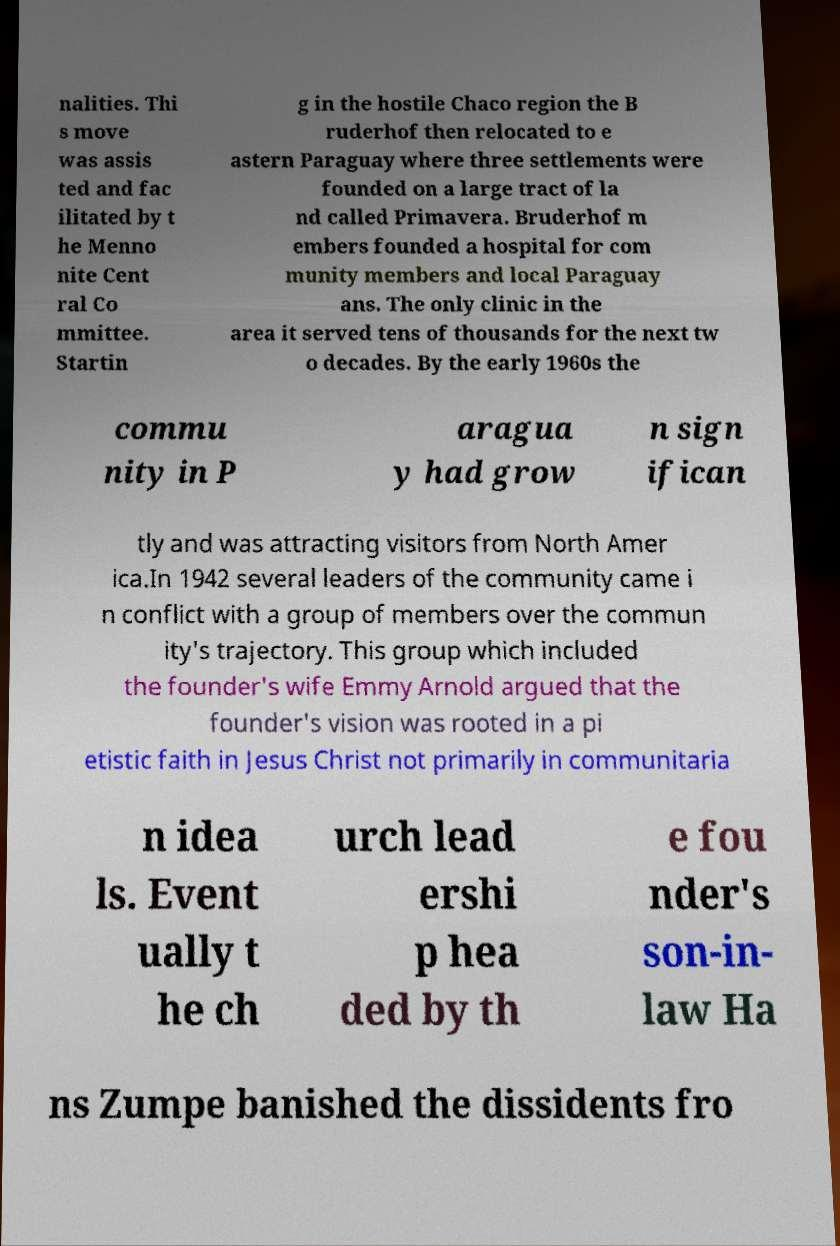What messages or text are displayed in this image? I need them in a readable, typed format. nalities. Thi s move was assis ted and fac ilitated by t he Menno nite Cent ral Co mmittee. Startin g in the hostile Chaco region the B ruderhof then relocated to e astern Paraguay where three settlements were founded on a large tract of la nd called Primavera. Bruderhof m embers founded a hospital for com munity members and local Paraguay ans. The only clinic in the area it served tens of thousands for the next tw o decades. By the early 1960s the commu nity in P aragua y had grow n sign ifican tly and was attracting visitors from North Amer ica.In 1942 several leaders of the community came i n conflict with a group of members over the commun ity's trajectory. This group which included the founder's wife Emmy Arnold argued that the founder's vision was rooted in a pi etistic faith in Jesus Christ not primarily in communitaria n idea ls. Event ually t he ch urch lead ershi p hea ded by th e fou nder's son-in- law Ha ns Zumpe banished the dissidents fro 